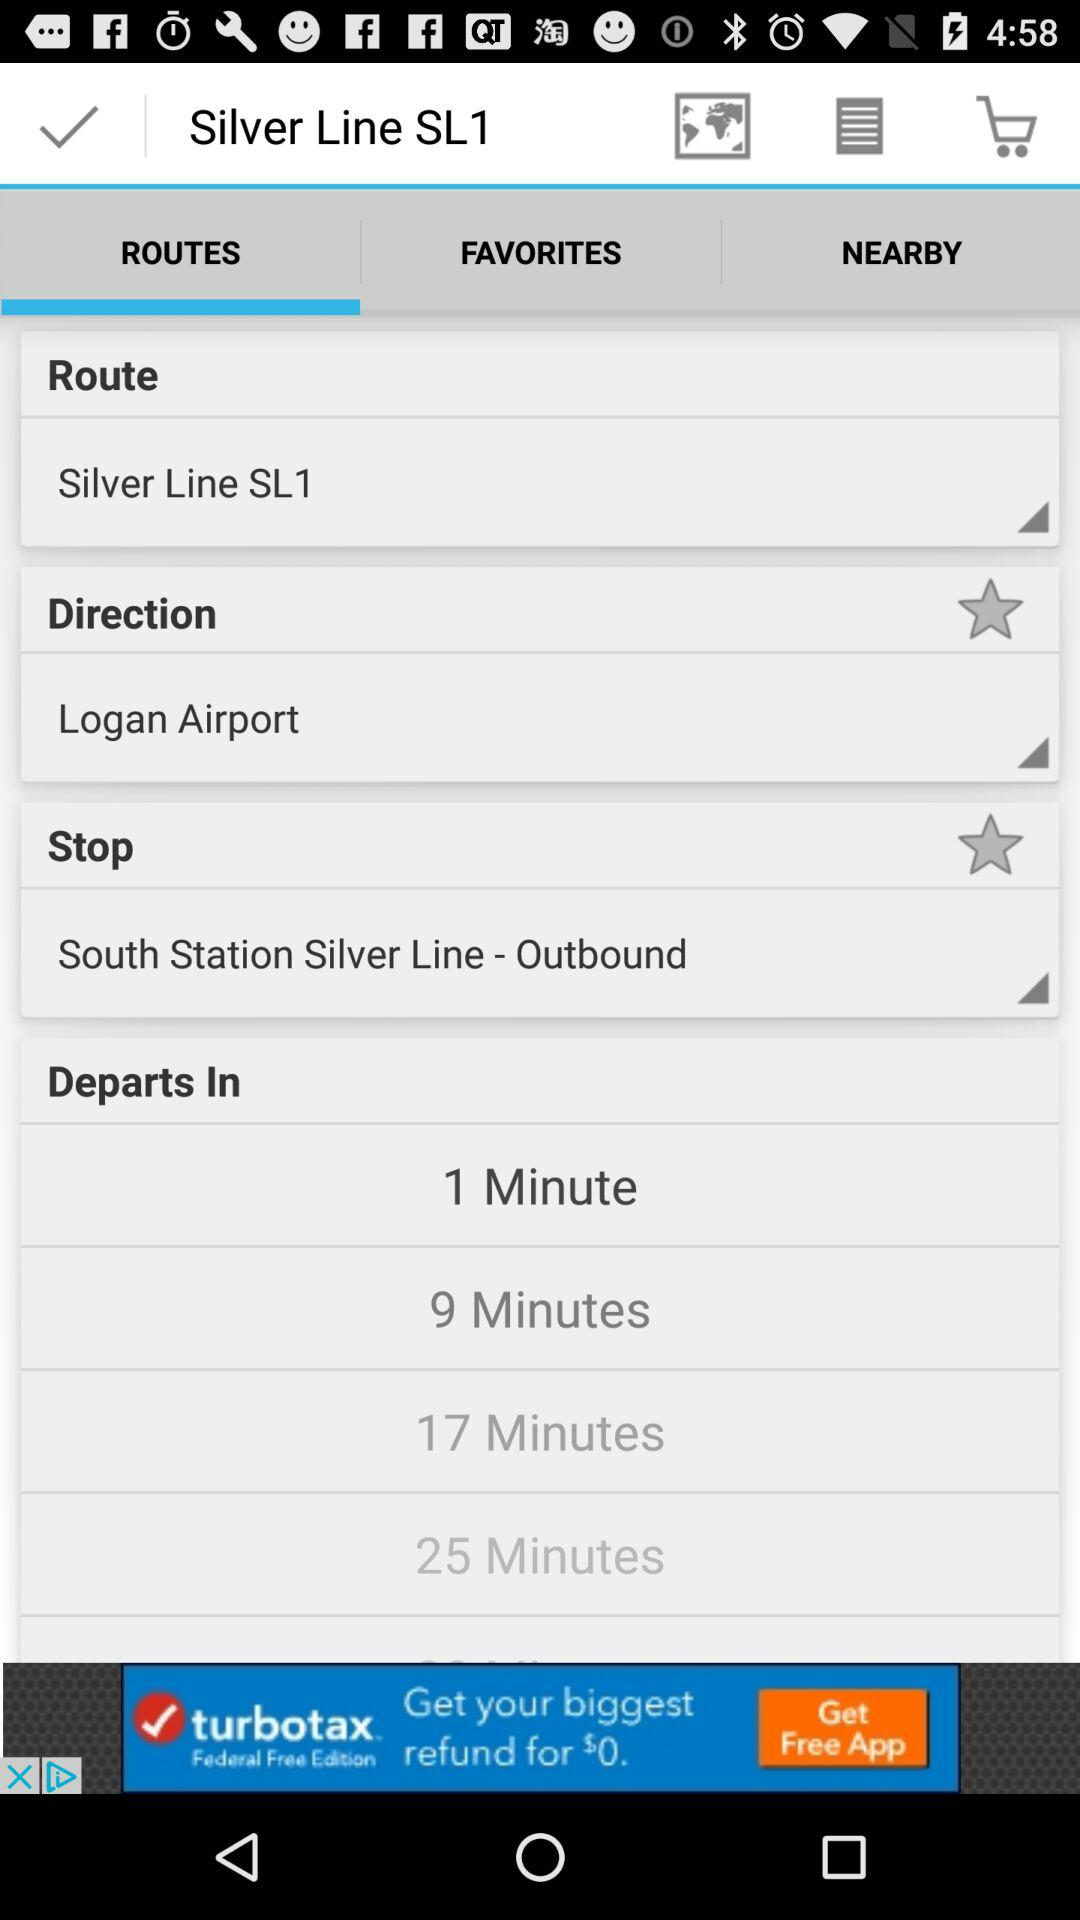What is the selected direction? The selected direction is "Logan Airport". 